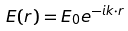Convert formula to latex. <formula><loc_0><loc_0><loc_500><loc_500>E ( r ) = E _ { 0 } e ^ { - i k \cdot r }</formula> 